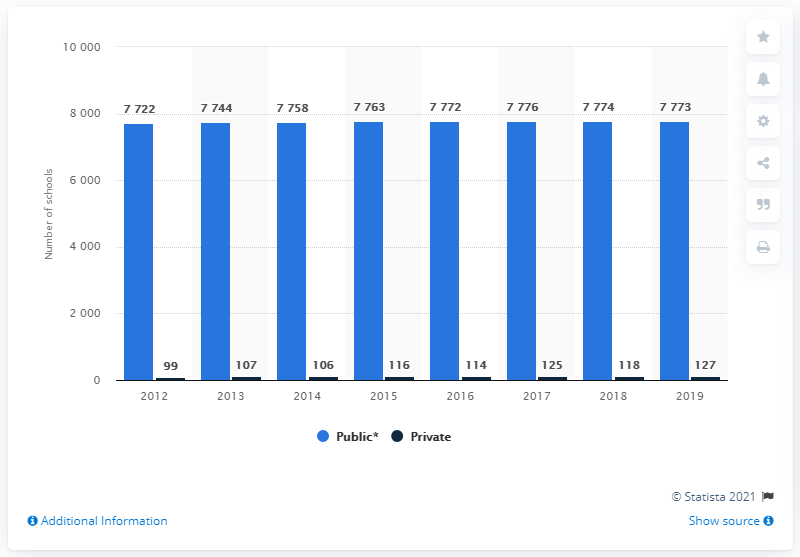Identify some key points in this picture. There were 127 private primary schools in Malaysia in 2019. In 2019, there were 7,773 primary schools in Malaysia. 